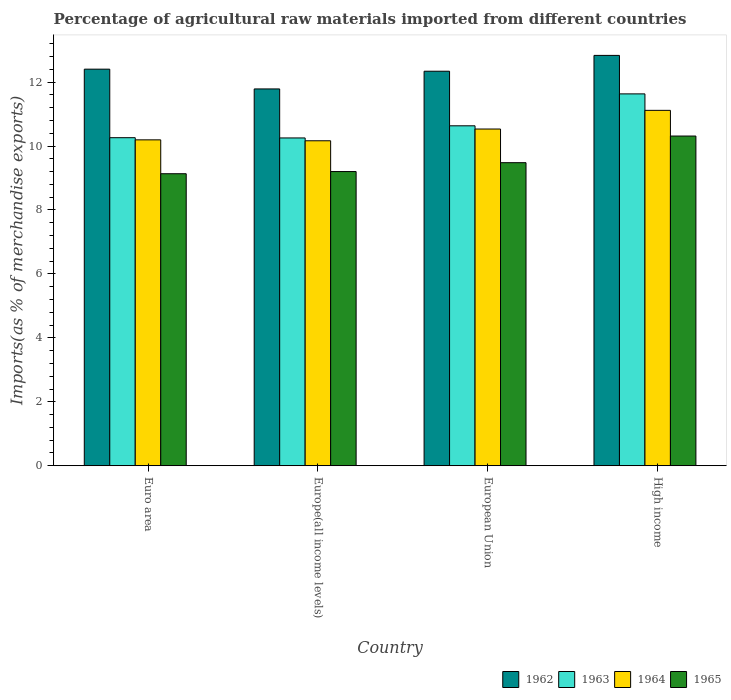Are the number of bars on each tick of the X-axis equal?
Your answer should be very brief. Yes. How many bars are there on the 4th tick from the left?
Ensure brevity in your answer.  4. How many bars are there on the 2nd tick from the right?
Offer a terse response. 4. What is the label of the 4th group of bars from the left?
Offer a very short reply. High income. What is the percentage of imports to different countries in 1965 in European Union?
Provide a succinct answer. 9.48. Across all countries, what is the maximum percentage of imports to different countries in 1965?
Your response must be concise. 10.31. Across all countries, what is the minimum percentage of imports to different countries in 1963?
Ensure brevity in your answer.  10.25. In which country was the percentage of imports to different countries in 1963 maximum?
Offer a very short reply. High income. In which country was the percentage of imports to different countries in 1964 minimum?
Make the answer very short. Europe(all income levels). What is the total percentage of imports to different countries in 1962 in the graph?
Make the answer very short. 49.37. What is the difference between the percentage of imports to different countries in 1965 in Europe(all income levels) and that in High income?
Ensure brevity in your answer.  -1.11. What is the difference between the percentage of imports to different countries in 1965 in Europe(all income levels) and the percentage of imports to different countries in 1962 in High income?
Provide a short and direct response. -3.63. What is the average percentage of imports to different countries in 1965 per country?
Offer a terse response. 9.53. What is the difference between the percentage of imports to different countries of/in 1963 and percentage of imports to different countries of/in 1965 in Euro area?
Ensure brevity in your answer.  1.13. In how many countries, is the percentage of imports to different countries in 1962 greater than 0.8 %?
Ensure brevity in your answer.  4. What is the ratio of the percentage of imports to different countries in 1962 in Euro area to that in Europe(all income levels)?
Offer a terse response. 1.05. Is the difference between the percentage of imports to different countries in 1963 in Europe(all income levels) and European Union greater than the difference between the percentage of imports to different countries in 1965 in Europe(all income levels) and European Union?
Keep it short and to the point. No. What is the difference between the highest and the second highest percentage of imports to different countries in 1962?
Your answer should be compact. 0.43. What is the difference between the highest and the lowest percentage of imports to different countries in 1963?
Your answer should be very brief. 1.38. What does the 3rd bar from the left in Euro area represents?
Provide a succinct answer. 1964. What does the 4th bar from the right in Europe(all income levels) represents?
Offer a terse response. 1962. How many bars are there?
Your answer should be very brief. 16. How many countries are there in the graph?
Offer a terse response. 4. Does the graph contain grids?
Your response must be concise. No. Where does the legend appear in the graph?
Ensure brevity in your answer.  Bottom right. What is the title of the graph?
Offer a very short reply. Percentage of agricultural raw materials imported from different countries. Does "1998" appear as one of the legend labels in the graph?
Keep it short and to the point. No. What is the label or title of the Y-axis?
Ensure brevity in your answer.  Imports(as % of merchandise exports). What is the Imports(as % of merchandise exports) in 1962 in Euro area?
Provide a succinct answer. 12.41. What is the Imports(as % of merchandise exports) in 1963 in Euro area?
Your answer should be compact. 10.26. What is the Imports(as % of merchandise exports) in 1964 in Euro area?
Ensure brevity in your answer.  10.19. What is the Imports(as % of merchandise exports) of 1965 in Euro area?
Ensure brevity in your answer.  9.13. What is the Imports(as % of merchandise exports) in 1962 in Europe(all income levels)?
Offer a terse response. 11.79. What is the Imports(as % of merchandise exports) of 1963 in Europe(all income levels)?
Offer a terse response. 10.25. What is the Imports(as % of merchandise exports) in 1964 in Europe(all income levels)?
Your answer should be very brief. 10.17. What is the Imports(as % of merchandise exports) in 1965 in Europe(all income levels)?
Provide a succinct answer. 9.2. What is the Imports(as % of merchandise exports) in 1962 in European Union?
Offer a terse response. 12.34. What is the Imports(as % of merchandise exports) in 1963 in European Union?
Provide a short and direct response. 10.63. What is the Imports(as % of merchandise exports) in 1964 in European Union?
Your answer should be compact. 10.53. What is the Imports(as % of merchandise exports) in 1965 in European Union?
Make the answer very short. 9.48. What is the Imports(as % of merchandise exports) of 1962 in High income?
Provide a succinct answer. 12.84. What is the Imports(as % of merchandise exports) in 1963 in High income?
Your answer should be compact. 11.63. What is the Imports(as % of merchandise exports) of 1964 in High income?
Offer a terse response. 11.12. What is the Imports(as % of merchandise exports) in 1965 in High income?
Offer a terse response. 10.31. Across all countries, what is the maximum Imports(as % of merchandise exports) in 1962?
Offer a terse response. 12.84. Across all countries, what is the maximum Imports(as % of merchandise exports) of 1963?
Your answer should be very brief. 11.63. Across all countries, what is the maximum Imports(as % of merchandise exports) in 1964?
Offer a very short reply. 11.12. Across all countries, what is the maximum Imports(as % of merchandise exports) in 1965?
Your response must be concise. 10.31. Across all countries, what is the minimum Imports(as % of merchandise exports) in 1962?
Your answer should be compact. 11.79. Across all countries, what is the minimum Imports(as % of merchandise exports) in 1963?
Your answer should be compact. 10.25. Across all countries, what is the minimum Imports(as % of merchandise exports) in 1964?
Make the answer very short. 10.17. Across all countries, what is the minimum Imports(as % of merchandise exports) in 1965?
Offer a terse response. 9.13. What is the total Imports(as % of merchandise exports) of 1962 in the graph?
Give a very brief answer. 49.37. What is the total Imports(as % of merchandise exports) of 1963 in the graph?
Ensure brevity in your answer.  42.78. What is the total Imports(as % of merchandise exports) of 1964 in the graph?
Offer a very short reply. 42.01. What is the total Imports(as % of merchandise exports) of 1965 in the graph?
Offer a very short reply. 38.13. What is the difference between the Imports(as % of merchandise exports) in 1962 in Euro area and that in Europe(all income levels)?
Keep it short and to the point. 0.62. What is the difference between the Imports(as % of merchandise exports) in 1963 in Euro area and that in Europe(all income levels)?
Provide a succinct answer. 0.01. What is the difference between the Imports(as % of merchandise exports) of 1964 in Euro area and that in Europe(all income levels)?
Offer a terse response. 0.03. What is the difference between the Imports(as % of merchandise exports) in 1965 in Euro area and that in Europe(all income levels)?
Provide a succinct answer. -0.07. What is the difference between the Imports(as % of merchandise exports) of 1962 in Euro area and that in European Union?
Keep it short and to the point. 0.06. What is the difference between the Imports(as % of merchandise exports) in 1963 in Euro area and that in European Union?
Offer a very short reply. -0.37. What is the difference between the Imports(as % of merchandise exports) of 1964 in Euro area and that in European Union?
Offer a very short reply. -0.34. What is the difference between the Imports(as % of merchandise exports) of 1965 in Euro area and that in European Union?
Ensure brevity in your answer.  -0.35. What is the difference between the Imports(as % of merchandise exports) in 1962 in Euro area and that in High income?
Your answer should be very brief. -0.43. What is the difference between the Imports(as % of merchandise exports) in 1963 in Euro area and that in High income?
Offer a very short reply. -1.37. What is the difference between the Imports(as % of merchandise exports) of 1964 in Euro area and that in High income?
Make the answer very short. -0.92. What is the difference between the Imports(as % of merchandise exports) of 1965 in Euro area and that in High income?
Ensure brevity in your answer.  -1.18. What is the difference between the Imports(as % of merchandise exports) in 1962 in Europe(all income levels) and that in European Union?
Your answer should be very brief. -0.55. What is the difference between the Imports(as % of merchandise exports) of 1963 in Europe(all income levels) and that in European Union?
Your response must be concise. -0.38. What is the difference between the Imports(as % of merchandise exports) in 1964 in Europe(all income levels) and that in European Union?
Make the answer very short. -0.37. What is the difference between the Imports(as % of merchandise exports) of 1965 in Europe(all income levels) and that in European Union?
Give a very brief answer. -0.28. What is the difference between the Imports(as % of merchandise exports) of 1962 in Europe(all income levels) and that in High income?
Provide a succinct answer. -1.05. What is the difference between the Imports(as % of merchandise exports) in 1963 in Europe(all income levels) and that in High income?
Ensure brevity in your answer.  -1.38. What is the difference between the Imports(as % of merchandise exports) in 1964 in Europe(all income levels) and that in High income?
Provide a short and direct response. -0.95. What is the difference between the Imports(as % of merchandise exports) of 1965 in Europe(all income levels) and that in High income?
Give a very brief answer. -1.11. What is the difference between the Imports(as % of merchandise exports) of 1962 in European Union and that in High income?
Offer a terse response. -0.5. What is the difference between the Imports(as % of merchandise exports) of 1963 in European Union and that in High income?
Make the answer very short. -1. What is the difference between the Imports(as % of merchandise exports) of 1964 in European Union and that in High income?
Provide a succinct answer. -0.58. What is the difference between the Imports(as % of merchandise exports) of 1965 in European Union and that in High income?
Give a very brief answer. -0.83. What is the difference between the Imports(as % of merchandise exports) of 1962 in Euro area and the Imports(as % of merchandise exports) of 1963 in Europe(all income levels)?
Offer a terse response. 2.15. What is the difference between the Imports(as % of merchandise exports) of 1962 in Euro area and the Imports(as % of merchandise exports) of 1964 in Europe(all income levels)?
Your answer should be compact. 2.24. What is the difference between the Imports(as % of merchandise exports) of 1962 in Euro area and the Imports(as % of merchandise exports) of 1965 in Europe(all income levels)?
Your answer should be very brief. 3.2. What is the difference between the Imports(as % of merchandise exports) of 1963 in Euro area and the Imports(as % of merchandise exports) of 1964 in Europe(all income levels)?
Offer a very short reply. 0.1. What is the difference between the Imports(as % of merchandise exports) in 1963 in Euro area and the Imports(as % of merchandise exports) in 1965 in Europe(all income levels)?
Make the answer very short. 1.06. What is the difference between the Imports(as % of merchandise exports) of 1964 in Euro area and the Imports(as % of merchandise exports) of 1965 in Europe(all income levels)?
Offer a terse response. 0.99. What is the difference between the Imports(as % of merchandise exports) in 1962 in Euro area and the Imports(as % of merchandise exports) in 1963 in European Union?
Provide a succinct answer. 1.77. What is the difference between the Imports(as % of merchandise exports) in 1962 in Euro area and the Imports(as % of merchandise exports) in 1964 in European Union?
Provide a short and direct response. 1.87. What is the difference between the Imports(as % of merchandise exports) of 1962 in Euro area and the Imports(as % of merchandise exports) of 1965 in European Union?
Your answer should be compact. 2.93. What is the difference between the Imports(as % of merchandise exports) in 1963 in Euro area and the Imports(as % of merchandise exports) in 1964 in European Union?
Your response must be concise. -0.27. What is the difference between the Imports(as % of merchandise exports) of 1963 in Euro area and the Imports(as % of merchandise exports) of 1965 in European Union?
Ensure brevity in your answer.  0.78. What is the difference between the Imports(as % of merchandise exports) in 1964 in Euro area and the Imports(as % of merchandise exports) in 1965 in European Union?
Provide a short and direct response. 0.71. What is the difference between the Imports(as % of merchandise exports) of 1962 in Euro area and the Imports(as % of merchandise exports) of 1963 in High income?
Your answer should be compact. 0.77. What is the difference between the Imports(as % of merchandise exports) in 1962 in Euro area and the Imports(as % of merchandise exports) in 1964 in High income?
Keep it short and to the point. 1.29. What is the difference between the Imports(as % of merchandise exports) of 1962 in Euro area and the Imports(as % of merchandise exports) of 1965 in High income?
Your response must be concise. 2.09. What is the difference between the Imports(as % of merchandise exports) of 1963 in Euro area and the Imports(as % of merchandise exports) of 1964 in High income?
Your response must be concise. -0.86. What is the difference between the Imports(as % of merchandise exports) in 1963 in Euro area and the Imports(as % of merchandise exports) in 1965 in High income?
Ensure brevity in your answer.  -0.05. What is the difference between the Imports(as % of merchandise exports) in 1964 in Euro area and the Imports(as % of merchandise exports) in 1965 in High income?
Make the answer very short. -0.12. What is the difference between the Imports(as % of merchandise exports) in 1962 in Europe(all income levels) and the Imports(as % of merchandise exports) in 1963 in European Union?
Give a very brief answer. 1.15. What is the difference between the Imports(as % of merchandise exports) in 1962 in Europe(all income levels) and the Imports(as % of merchandise exports) in 1964 in European Union?
Give a very brief answer. 1.25. What is the difference between the Imports(as % of merchandise exports) of 1962 in Europe(all income levels) and the Imports(as % of merchandise exports) of 1965 in European Union?
Give a very brief answer. 2.31. What is the difference between the Imports(as % of merchandise exports) of 1963 in Europe(all income levels) and the Imports(as % of merchandise exports) of 1964 in European Union?
Offer a very short reply. -0.28. What is the difference between the Imports(as % of merchandise exports) of 1963 in Europe(all income levels) and the Imports(as % of merchandise exports) of 1965 in European Union?
Ensure brevity in your answer.  0.77. What is the difference between the Imports(as % of merchandise exports) in 1964 in Europe(all income levels) and the Imports(as % of merchandise exports) in 1965 in European Union?
Make the answer very short. 0.68. What is the difference between the Imports(as % of merchandise exports) in 1962 in Europe(all income levels) and the Imports(as % of merchandise exports) in 1963 in High income?
Provide a short and direct response. 0.15. What is the difference between the Imports(as % of merchandise exports) in 1962 in Europe(all income levels) and the Imports(as % of merchandise exports) in 1964 in High income?
Your answer should be very brief. 0.67. What is the difference between the Imports(as % of merchandise exports) in 1962 in Europe(all income levels) and the Imports(as % of merchandise exports) in 1965 in High income?
Provide a succinct answer. 1.47. What is the difference between the Imports(as % of merchandise exports) of 1963 in Europe(all income levels) and the Imports(as % of merchandise exports) of 1964 in High income?
Make the answer very short. -0.86. What is the difference between the Imports(as % of merchandise exports) of 1963 in Europe(all income levels) and the Imports(as % of merchandise exports) of 1965 in High income?
Offer a very short reply. -0.06. What is the difference between the Imports(as % of merchandise exports) in 1964 in Europe(all income levels) and the Imports(as % of merchandise exports) in 1965 in High income?
Provide a succinct answer. -0.15. What is the difference between the Imports(as % of merchandise exports) of 1962 in European Union and the Imports(as % of merchandise exports) of 1963 in High income?
Offer a terse response. 0.71. What is the difference between the Imports(as % of merchandise exports) in 1962 in European Union and the Imports(as % of merchandise exports) in 1964 in High income?
Keep it short and to the point. 1.22. What is the difference between the Imports(as % of merchandise exports) in 1962 in European Union and the Imports(as % of merchandise exports) in 1965 in High income?
Offer a terse response. 2.03. What is the difference between the Imports(as % of merchandise exports) in 1963 in European Union and the Imports(as % of merchandise exports) in 1964 in High income?
Make the answer very short. -0.48. What is the difference between the Imports(as % of merchandise exports) of 1963 in European Union and the Imports(as % of merchandise exports) of 1965 in High income?
Your answer should be compact. 0.32. What is the difference between the Imports(as % of merchandise exports) of 1964 in European Union and the Imports(as % of merchandise exports) of 1965 in High income?
Your answer should be compact. 0.22. What is the average Imports(as % of merchandise exports) of 1962 per country?
Offer a very short reply. 12.34. What is the average Imports(as % of merchandise exports) in 1963 per country?
Your answer should be very brief. 10.7. What is the average Imports(as % of merchandise exports) of 1964 per country?
Keep it short and to the point. 10.5. What is the average Imports(as % of merchandise exports) in 1965 per country?
Provide a succinct answer. 9.53. What is the difference between the Imports(as % of merchandise exports) of 1962 and Imports(as % of merchandise exports) of 1963 in Euro area?
Your response must be concise. 2.14. What is the difference between the Imports(as % of merchandise exports) of 1962 and Imports(as % of merchandise exports) of 1964 in Euro area?
Ensure brevity in your answer.  2.21. What is the difference between the Imports(as % of merchandise exports) of 1962 and Imports(as % of merchandise exports) of 1965 in Euro area?
Give a very brief answer. 3.27. What is the difference between the Imports(as % of merchandise exports) in 1963 and Imports(as % of merchandise exports) in 1964 in Euro area?
Make the answer very short. 0.07. What is the difference between the Imports(as % of merchandise exports) in 1963 and Imports(as % of merchandise exports) in 1965 in Euro area?
Give a very brief answer. 1.13. What is the difference between the Imports(as % of merchandise exports) in 1964 and Imports(as % of merchandise exports) in 1965 in Euro area?
Ensure brevity in your answer.  1.06. What is the difference between the Imports(as % of merchandise exports) in 1962 and Imports(as % of merchandise exports) in 1963 in Europe(all income levels)?
Provide a succinct answer. 1.53. What is the difference between the Imports(as % of merchandise exports) in 1962 and Imports(as % of merchandise exports) in 1964 in Europe(all income levels)?
Provide a succinct answer. 1.62. What is the difference between the Imports(as % of merchandise exports) of 1962 and Imports(as % of merchandise exports) of 1965 in Europe(all income levels)?
Give a very brief answer. 2.58. What is the difference between the Imports(as % of merchandise exports) in 1963 and Imports(as % of merchandise exports) in 1964 in Europe(all income levels)?
Ensure brevity in your answer.  0.09. What is the difference between the Imports(as % of merchandise exports) in 1963 and Imports(as % of merchandise exports) in 1965 in Europe(all income levels)?
Provide a short and direct response. 1.05. What is the difference between the Imports(as % of merchandise exports) of 1964 and Imports(as % of merchandise exports) of 1965 in Europe(all income levels)?
Your answer should be compact. 0.96. What is the difference between the Imports(as % of merchandise exports) of 1962 and Imports(as % of merchandise exports) of 1963 in European Union?
Make the answer very short. 1.71. What is the difference between the Imports(as % of merchandise exports) of 1962 and Imports(as % of merchandise exports) of 1964 in European Union?
Provide a succinct answer. 1.81. What is the difference between the Imports(as % of merchandise exports) in 1962 and Imports(as % of merchandise exports) in 1965 in European Union?
Provide a short and direct response. 2.86. What is the difference between the Imports(as % of merchandise exports) in 1963 and Imports(as % of merchandise exports) in 1964 in European Union?
Offer a terse response. 0.1. What is the difference between the Imports(as % of merchandise exports) in 1963 and Imports(as % of merchandise exports) in 1965 in European Union?
Your response must be concise. 1.15. What is the difference between the Imports(as % of merchandise exports) of 1964 and Imports(as % of merchandise exports) of 1965 in European Union?
Provide a succinct answer. 1.05. What is the difference between the Imports(as % of merchandise exports) of 1962 and Imports(as % of merchandise exports) of 1963 in High income?
Provide a succinct answer. 1.2. What is the difference between the Imports(as % of merchandise exports) of 1962 and Imports(as % of merchandise exports) of 1964 in High income?
Your answer should be very brief. 1.72. What is the difference between the Imports(as % of merchandise exports) in 1962 and Imports(as % of merchandise exports) in 1965 in High income?
Provide a succinct answer. 2.52. What is the difference between the Imports(as % of merchandise exports) in 1963 and Imports(as % of merchandise exports) in 1964 in High income?
Keep it short and to the point. 0.52. What is the difference between the Imports(as % of merchandise exports) of 1963 and Imports(as % of merchandise exports) of 1965 in High income?
Offer a very short reply. 1.32. What is the difference between the Imports(as % of merchandise exports) in 1964 and Imports(as % of merchandise exports) in 1965 in High income?
Make the answer very short. 0.8. What is the ratio of the Imports(as % of merchandise exports) in 1962 in Euro area to that in Europe(all income levels)?
Your answer should be compact. 1.05. What is the ratio of the Imports(as % of merchandise exports) in 1963 in Euro area to that in Europe(all income levels)?
Your response must be concise. 1. What is the ratio of the Imports(as % of merchandise exports) in 1964 in Euro area to that in Europe(all income levels)?
Offer a terse response. 1. What is the ratio of the Imports(as % of merchandise exports) of 1964 in Euro area to that in European Union?
Ensure brevity in your answer.  0.97. What is the ratio of the Imports(as % of merchandise exports) of 1965 in Euro area to that in European Union?
Provide a succinct answer. 0.96. What is the ratio of the Imports(as % of merchandise exports) of 1962 in Euro area to that in High income?
Offer a terse response. 0.97. What is the ratio of the Imports(as % of merchandise exports) in 1963 in Euro area to that in High income?
Offer a very short reply. 0.88. What is the ratio of the Imports(as % of merchandise exports) of 1964 in Euro area to that in High income?
Your answer should be very brief. 0.92. What is the ratio of the Imports(as % of merchandise exports) in 1965 in Euro area to that in High income?
Your answer should be very brief. 0.89. What is the ratio of the Imports(as % of merchandise exports) of 1962 in Europe(all income levels) to that in European Union?
Ensure brevity in your answer.  0.96. What is the ratio of the Imports(as % of merchandise exports) of 1963 in Europe(all income levels) to that in European Union?
Offer a very short reply. 0.96. What is the ratio of the Imports(as % of merchandise exports) in 1964 in Europe(all income levels) to that in European Union?
Ensure brevity in your answer.  0.97. What is the ratio of the Imports(as % of merchandise exports) in 1965 in Europe(all income levels) to that in European Union?
Your answer should be compact. 0.97. What is the ratio of the Imports(as % of merchandise exports) in 1962 in Europe(all income levels) to that in High income?
Your answer should be very brief. 0.92. What is the ratio of the Imports(as % of merchandise exports) in 1963 in Europe(all income levels) to that in High income?
Offer a terse response. 0.88. What is the ratio of the Imports(as % of merchandise exports) of 1964 in Europe(all income levels) to that in High income?
Keep it short and to the point. 0.91. What is the ratio of the Imports(as % of merchandise exports) in 1965 in Europe(all income levels) to that in High income?
Provide a succinct answer. 0.89. What is the ratio of the Imports(as % of merchandise exports) in 1962 in European Union to that in High income?
Give a very brief answer. 0.96. What is the ratio of the Imports(as % of merchandise exports) in 1963 in European Union to that in High income?
Offer a very short reply. 0.91. What is the ratio of the Imports(as % of merchandise exports) of 1964 in European Union to that in High income?
Your answer should be very brief. 0.95. What is the ratio of the Imports(as % of merchandise exports) of 1965 in European Union to that in High income?
Provide a short and direct response. 0.92. What is the difference between the highest and the second highest Imports(as % of merchandise exports) of 1962?
Your answer should be very brief. 0.43. What is the difference between the highest and the second highest Imports(as % of merchandise exports) of 1963?
Provide a succinct answer. 1. What is the difference between the highest and the second highest Imports(as % of merchandise exports) of 1964?
Ensure brevity in your answer.  0.58. What is the difference between the highest and the second highest Imports(as % of merchandise exports) in 1965?
Your answer should be compact. 0.83. What is the difference between the highest and the lowest Imports(as % of merchandise exports) of 1962?
Your answer should be compact. 1.05. What is the difference between the highest and the lowest Imports(as % of merchandise exports) in 1963?
Provide a short and direct response. 1.38. What is the difference between the highest and the lowest Imports(as % of merchandise exports) of 1964?
Provide a succinct answer. 0.95. What is the difference between the highest and the lowest Imports(as % of merchandise exports) of 1965?
Your answer should be compact. 1.18. 